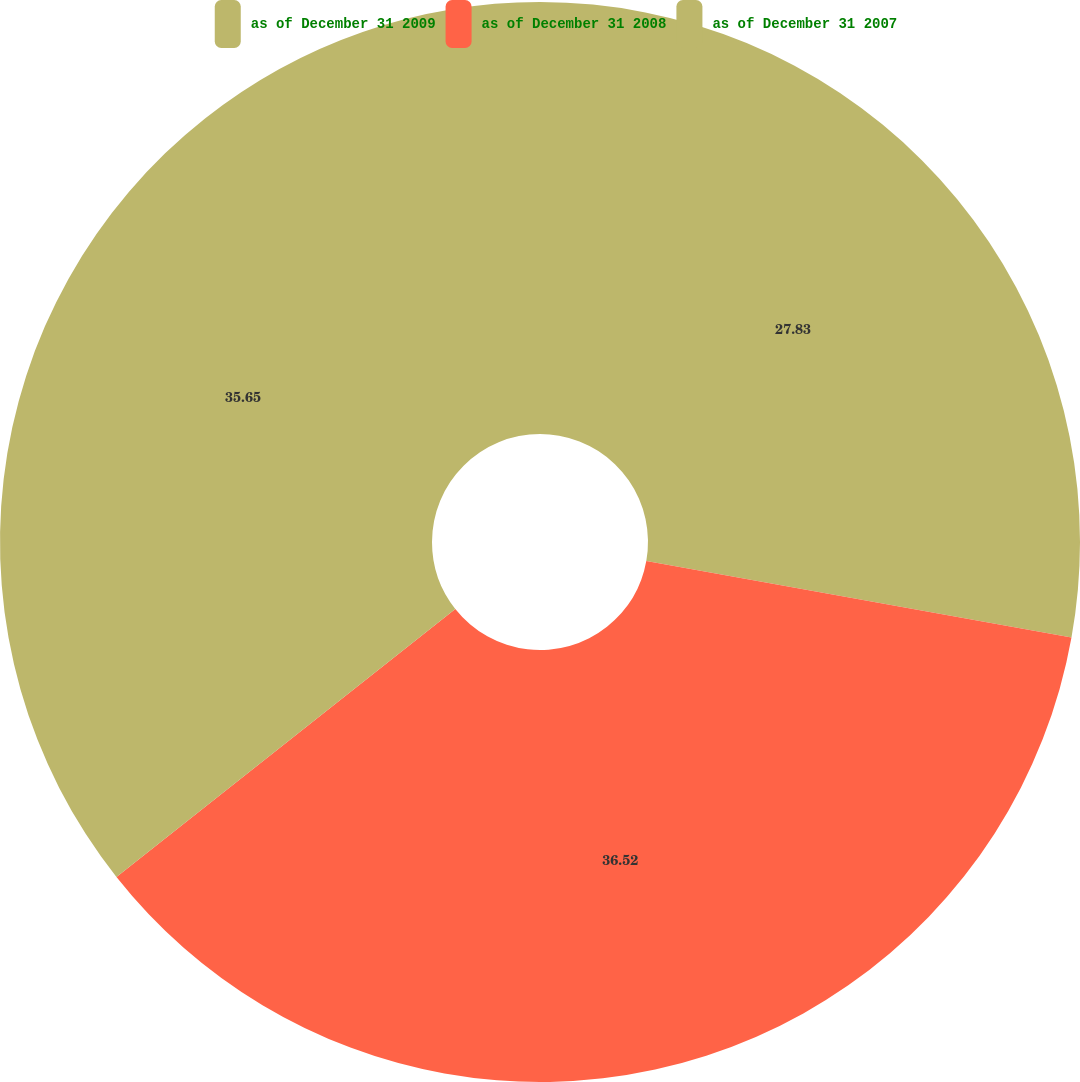Convert chart. <chart><loc_0><loc_0><loc_500><loc_500><pie_chart><fcel>as of December 31 2009<fcel>as of December 31 2008<fcel>as of December 31 2007<nl><fcel>27.83%<fcel>36.52%<fcel>35.65%<nl></chart> 